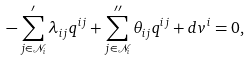Convert formula to latex. <formula><loc_0><loc_0><loc_500><loc_500>- \sum _ { j \in { \mathcal { N } } _ { i } } ^ { \prime } \lambda _ { i j } { q } ^ { i j } + \sum _ { j \in { \mathcal { N } } _ { i } } ^ { \prime \prime } \theta _ { i j } { q } ^ { i j } + d { v } ^ { i } = 0 ,</formula> 